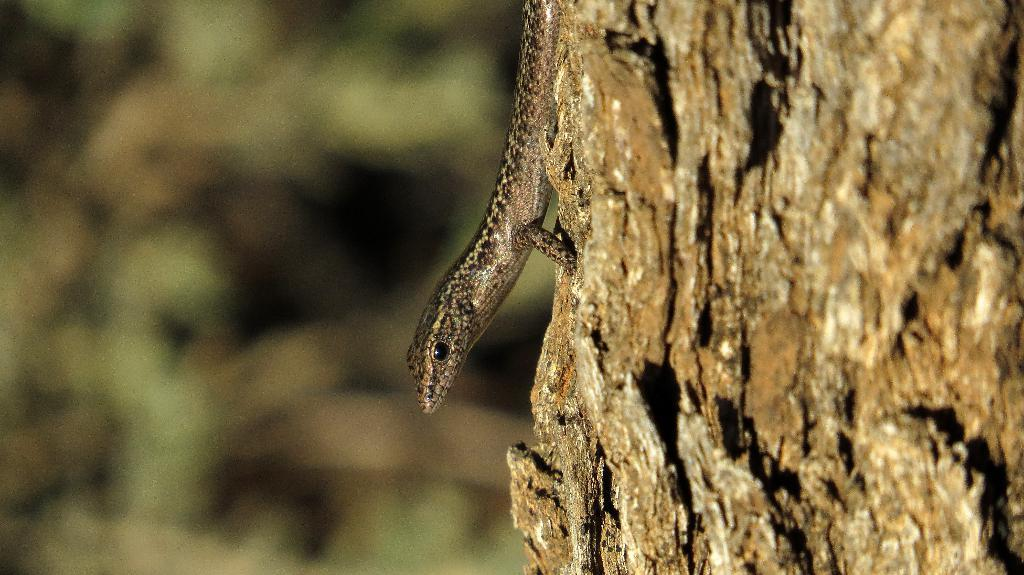What type of animal is in the image? There is a lizard in the image. Where is the lizard located? The lizard is on a tree trunk. Can you describe the background of the image? The background of the image is blurry. What type of process is the actor performing in the image? There is no actor or process present in the image; it features a lizard on a tree trunk with a blurry background. 